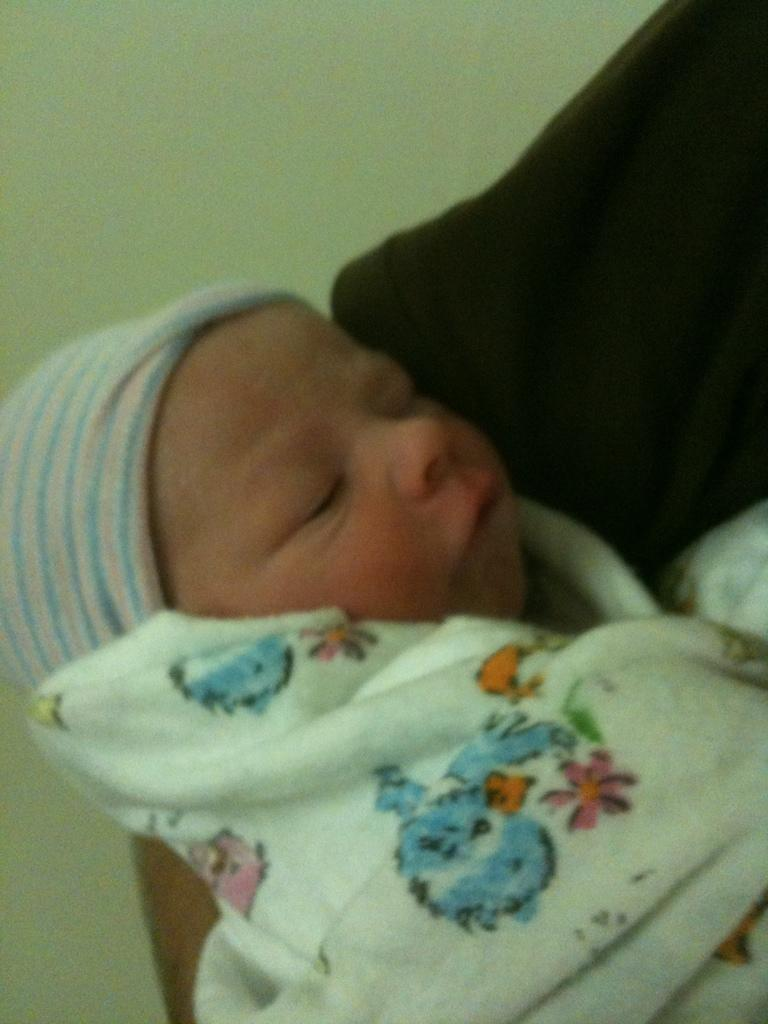What is the main subject of the image? There is a small baby in the image. How is the baby positioned or covered in the image? The baby is covered with a blanket. Can you see any part of a person in the image? Yes, there is a person's hand visible in the image. What type of oil is being used to guide the baby in the image? There is no oil or guiding action involving the baby in the image. 